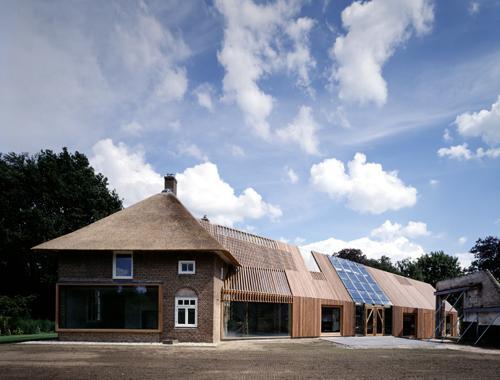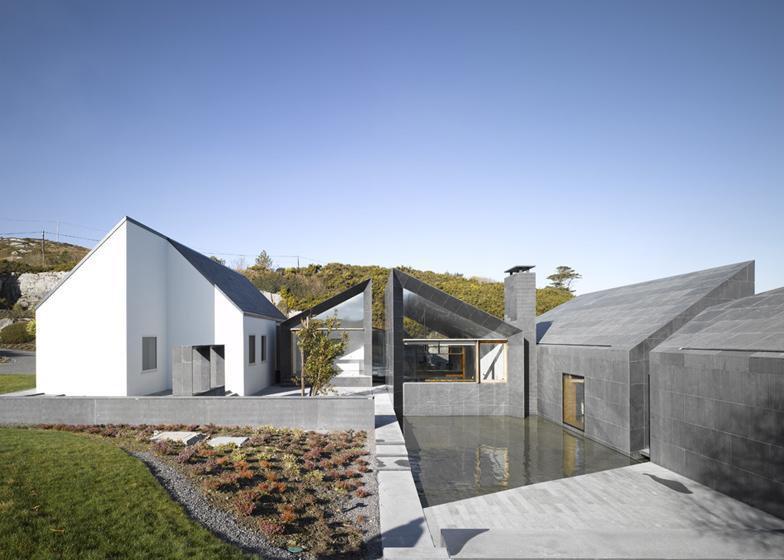The first image is the image on the left, the second image is the image on the right. Analyze the images presented: Is the assertion "A mid century modern house has a flat roof." valid? Answer yes or no. No. The first image is the image on the left, the second image is the image on the right. Considering the images on both sides, is "One of the homes has a flat roof and the other has angular roof lines." valid? Answer yes or no. No. 